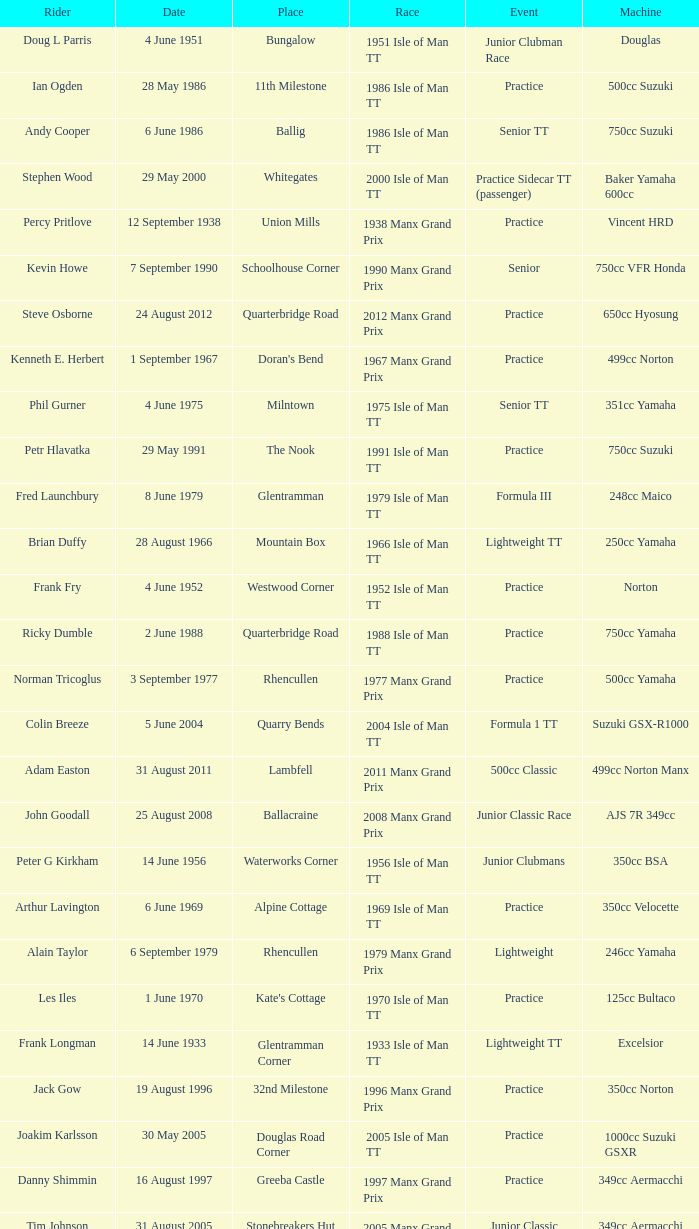Where was the 249cc Yamaha? Glentramman. 